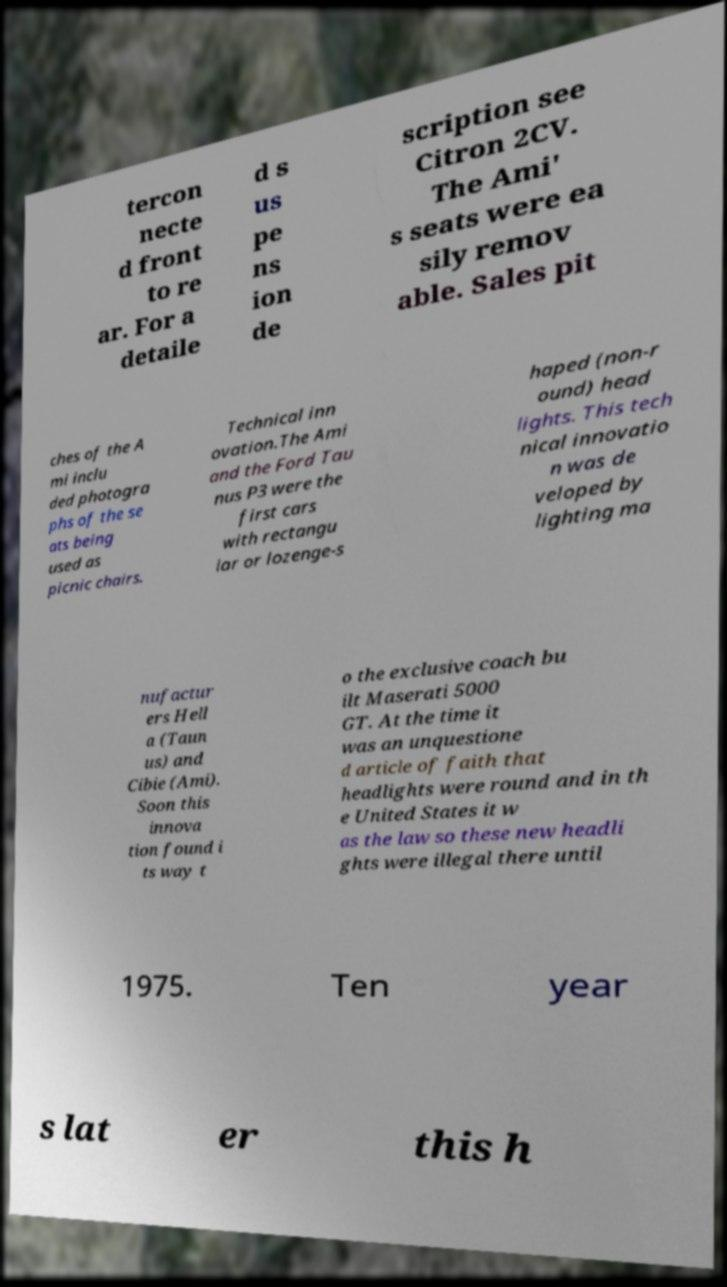Can you accurately transcribe the text from the provided image for me? tercon necte d front to re ar. For a detaile d s us pe ns ion de scription see Citron 2CV. The Ami' s seats were ea sily remov able. Sales pit ches of the A mi inclu ded photogra phs of the se ats being used as picnic chairs. Technical inn ovation.The Ami and the Ford Tau nus P3 were the first cars with rectangu lar or lozenge-s haped (non-r ound) head lights. This tech nical innovatio n was de veloped by lighting ma nufactur ers Hell a (Taun us) and Cibie (Ami). Soon this innova tion found i ts way t o the exclusive coach bu ilt Maserati 5000 GT. At the time it was an unquestione d article of faith that headlights were round and in th e United States it w as the law so these new headli ghts were illegal there until 1975. Ten year s lat er this h 